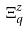<formula> <loc_0><loc_0><loc_500><loc_500>\Xi _ { q } ^ { z }</formula> 